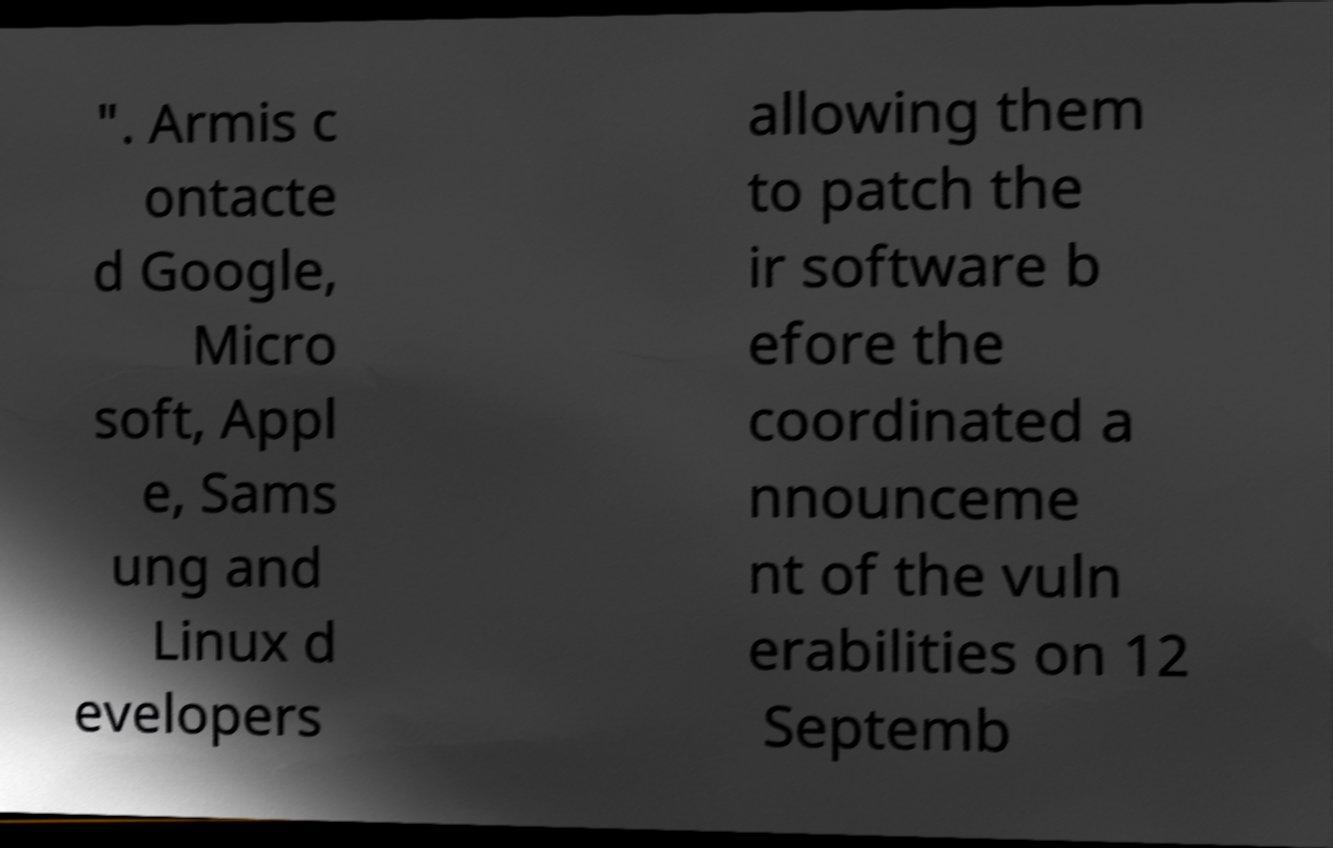Could you assist in decoding the text presented in this image and type it out clearly? ". Armis c ontacte d Google, Micro soft, Appl e, Sams ung and Linux d evelopers allowing them to patch the ir software b efore the coordinated a nnounceme nt of the vuln erabilities on 12 Septemb 